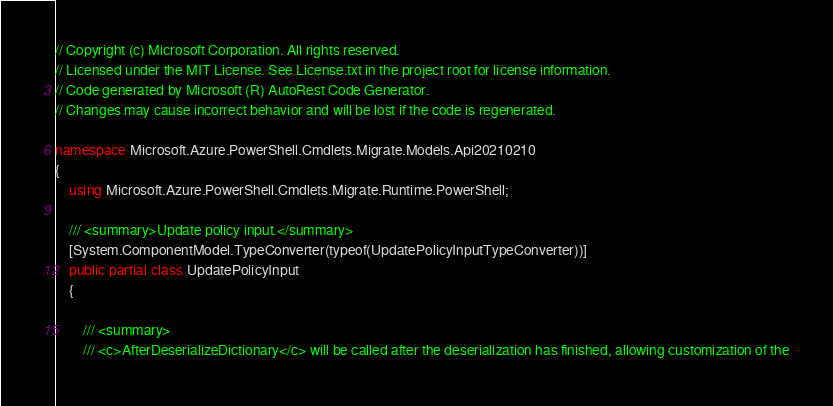Convert code to text. <code><loc_0><loc_0><loc_500><loc_500><_C#_>// Copyright (c) Microsoft Corporation. All rights reserved.
// Licensed under the MIT License. See License.txt in the project root for license information.
// Code generated by Microsoft (R) AutoRest Code Generator.
// Changes may cause incorrect behavior and will be lost if the code is regenerated.

namespace Microsoft.Azure.PowerShell.Cmdlets.Migrate.Models.Api20210210
{
    using Microsoft.Azure.PowerShell.Cmdlets.Migrate.Runtime.PowerShell;

    /// <summary>Update policy input.</summary>
    [System.ComponentModel.TypeConverter(typeof(UpdatePolicyInputTypeConverter))]
    public partial class UpdatePolicyInput
    {

        /// <summary>
        /// <c>AfterDeserializeDictionary</c> will be called after the deserialization has finished, allowing customization of the</code> 